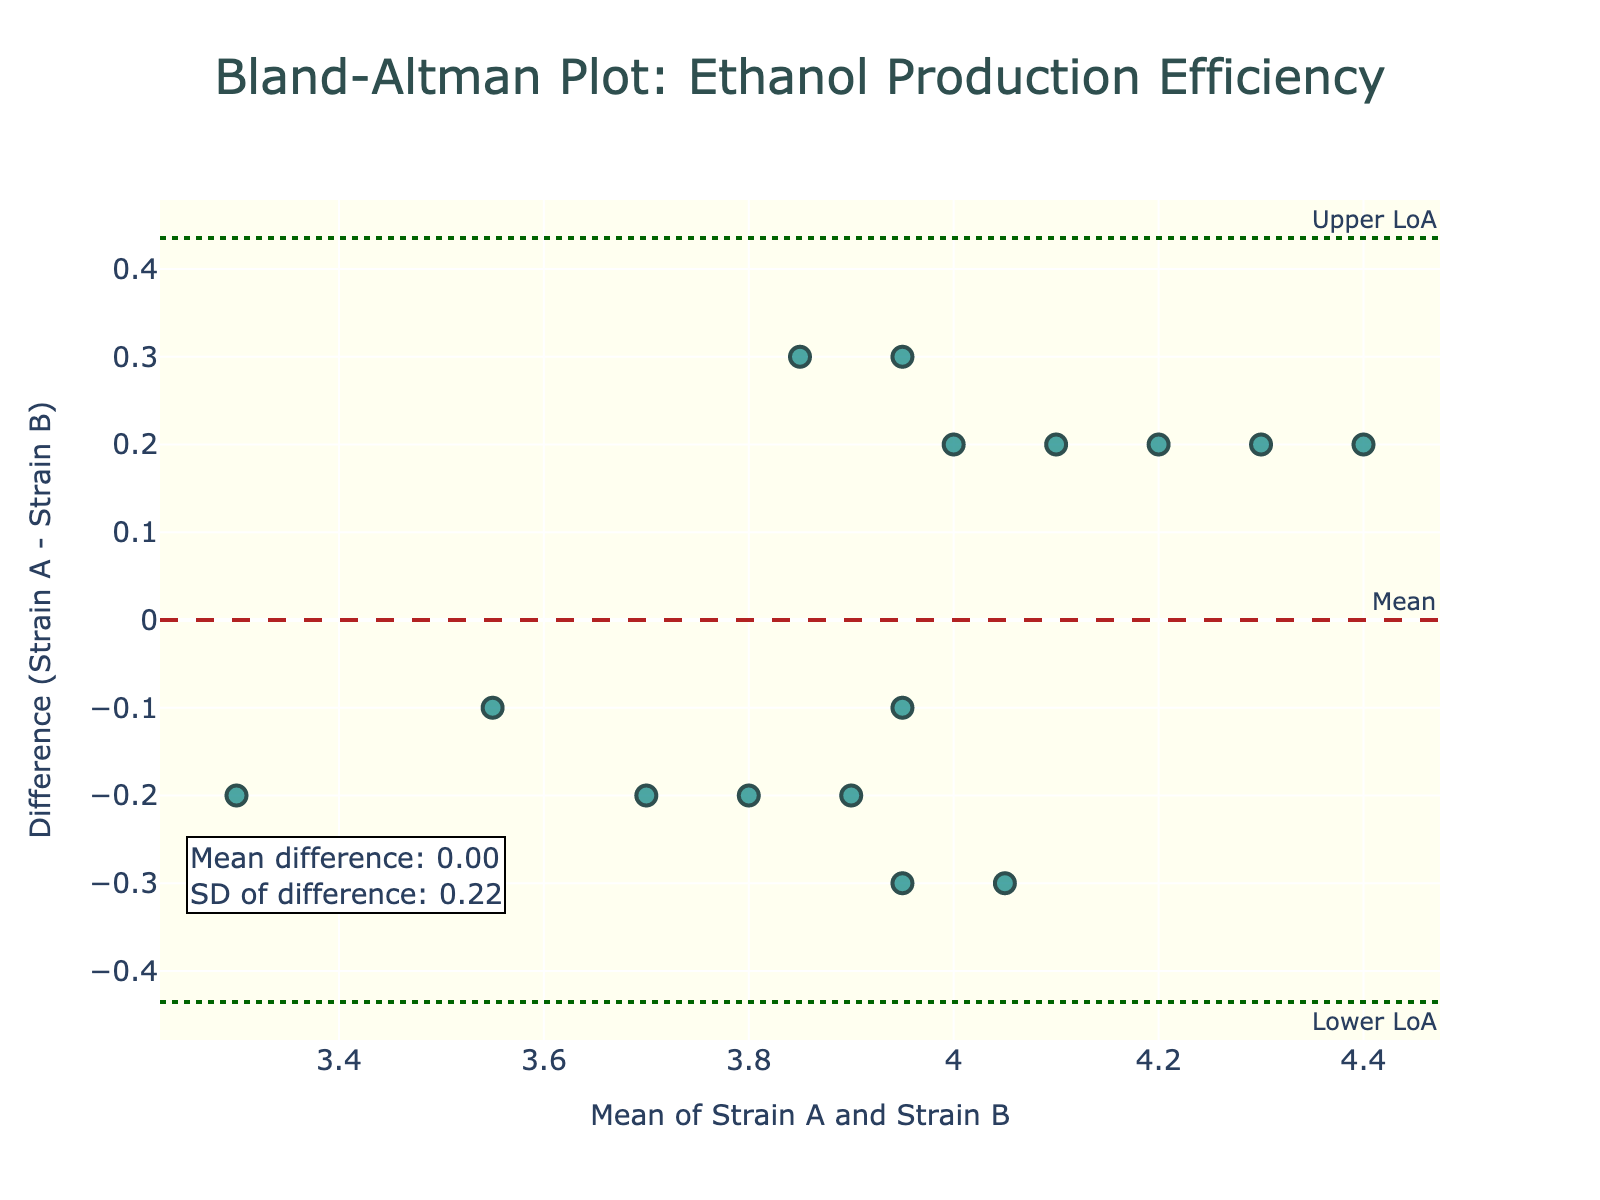What is the main title of the plot? The main title is usually located at the top of the plot and is a concise description of the plot's content. In this case, it is "Bland-Altman Plot: Ethanol Production Efficiency".
Answer: Bland-Altman Plot: Ethanol Production Efficiency What are the x-axis and y-axis labels in the plot? The x-axis label usually describes what the x-values represent, while the y-axis label describes what the y-values represent. Here, the x-axis is labeled "Mean of Strain A and Strain B" and the y-axis is labeled "Difference (Strain A - Strain B)".
Answer: Mean of Strain A and Strain B; Difference (Strain A - Strain B) How many data points are plotted on the graph? Count the number of markers (dots) on the graph to determine the number of data points. In this plot, there are 15 data points, corresponding to the number of pairs of observations.
Answer: 15 What is the mean difference between Strain A and Strain B? The mean difference is often annotated on the plot itself or can be derived from the data. In this case, it is given in an annotation as "Mean difference: -0.10".
Answer: -0.10 What are the upper and lower limits of agreement? The limits of agreement are typically indicated by dashed lines and annotations on the plot. Here, they are marked as "Upper LoA" and "Lower LoA" and are provided within the plot. The upper limit is approximately 0.13, and the lower limit is approximately -0.33.
Answer: Upper LoA: 0.13; Lower LoA: -0.33 What is the range of the values on the x-axis (mean of Strain A and Strain B)? Examine the x-axis to determine the minimum and maximum values shown on the axis. The range spans from approximately 3.3 to 4.4.
Answer: 3.3 to 4.4 Are there more data points above or below the mean difference line? This requires visually counting the number of points above and below the horizontal mean difference line, which is dashed. There are 7 points above and 8 points below the line.
Answer: Below Based on the plot, which strain generally produces more ethanol? Observing whether most differences are positive or negative can indicate which strain is generally higher. Here, most of the differences are negative, indicating Strain B generally produces more ethanol.
Answer: Strain B What is the standard deviation of the differences between Strain A and Strain B? The standard deviation is usually provided in the annotations on the plot. In this case, it is given as "SD of difference: 0.11".
Answer: 0.11 Is there any systematic bias evident between the two strains? To determine systematic bias, observe whether the mean difference (indicated by the dashed mean line) significantly deviates from 0. Here, the mean difference is -0.10, indicating a slight systematic bias where Strain B tends to produce slightly more ethanol.
Answer: Yes, slight bias in favor of Strain B 